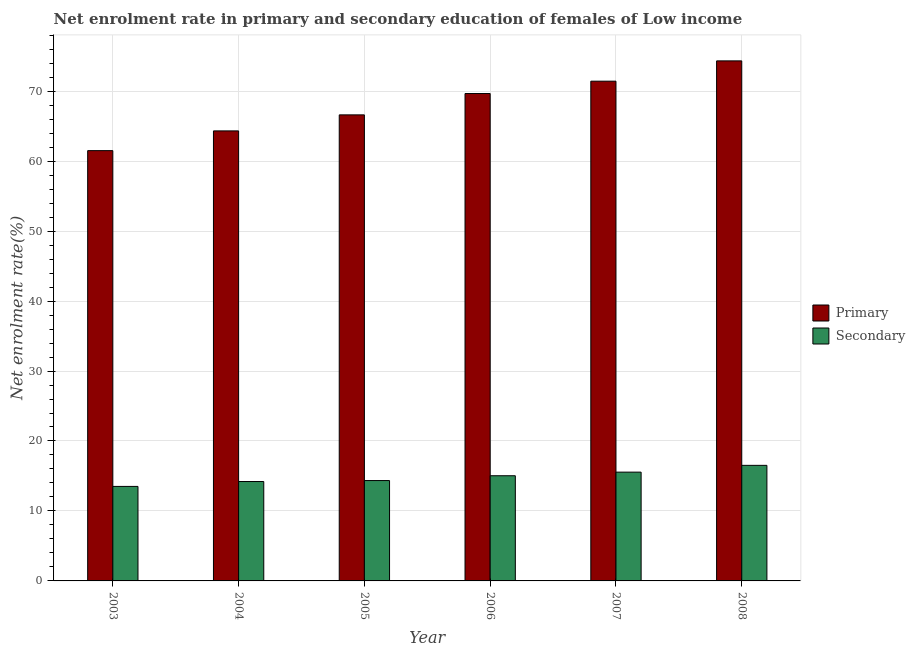How many different coloured bars are there?
Make the answer very short. 2. Are the number of bars per tick equal to the number of legend labels?
Make the answer very short. Yes. How many bars are there on the 2nd tick from the right?
Make the answer very short. 2. What is the label of the 4th group of bars from the left?
Your answer should be very brief. 2006. In how many cases, is the number of bars for a given year not equal to the number of legend labels?
Provide a short and direct response. 0. What is the enrollment rate in secondary education in 2008?
Your answer should be very brief. 16.52. Across all years, what is the maximum enrollment rate in primary education?
Keep it short and to the point. 74.33. Across all years, what is the minimum enrollment rate in primary education?
Provide a succinct answer. 61.5. In which year was the enrollment rate in primary education maximum?
Keep it short and to the point. 2008. What is the total enrollment rate in primary education in the graph?
Your answer should be compact. 407.84. What is the difference between the enrollment rate in primary education in 2006 and that in 2007?
Offer a very short reply. -1.77. What is the difference between the enrollment rate in secondary education in 2005 and the enrollment rate in primary education in 2006?
Your answer should be very brief. -0.69. What is the average enrollment rate in secondary education per year?
Ensure brevity in your answer.  14.86. What is the ratio of the enrollment rate in secondary education in 2005 to that in 2006?
Your answer should be compact. 0.95. Is the enrollment rate in secondary education in 2003 less than that in 2005?
Your response must be concise. Yes. What is the difference between the highest and the second highest enrollment rate in secondary education?
Your answer should be very brief. 0.97. What is the difference between the highest and the lowest enrollment rate in secondary education?
Your answer should be compact. 3.01. In how many years, is the enrollment rate in primary education greater than the average enrollment rate in primary education taken over all years?
Your answer should be compact. 3. What does the 1st bar from the left in 2007 represents?
Your answer should be very brief. Primary. What does the 1st bar from the right in 2005 represents?
Keep it short and to the point. Secondary. How many bars are there?
Your answer should be compact. 12. How many years are there in the graph?
Give a very brief answer. 6. What is the difference between two consecutive major ticks on the Y-axis?
Your answer should be compact. 10. Does the graph contain any zero values?
Give a very brief answer. No. Does the graph contain grids?
Your answer should be very brief. Yes. How many legend labels are there?
Your answer should be very brief. 2. How are the legend labels stacked?
Provide a succinct answer. Vertical. What is the title of the graph?
Your answer should be compact. Net enrolment rate in primary and secondary education of females of Low income. Does "Passenger Transport Items" appear as one of the legend labels in the graph?
Offer a terse response. No. What is the label or title of the X-axis?
Your answer should be very brief. Year. What is the label or title of the Y-axis?
Make the answer very short. Net enrolment rate(%). What is the Net enrolment rate(%) in Primary in 2003?
Provide a short and direct response. 61.5. What is the Net enrolment rate(%) in Secondary in 2003?
Make the answer very short. 13.51. What is the Net enrolment rate(%) in Primary in 2004?
Offer a terse response. 64.32. What is the Net enrolment rate(%) in Secondary in 2004?
Provide a succinct answer. 14.21. What is the Net enrolment rate(%) in Primary in 2005?
Provide a short and direct response. 66.61. What is the Net enrolment rate(%) of Secondary in 2005?
Your answer should be very brief. 14.35. What is the Net enrolment rate(%) of Primary in 2006?
Ensure brevity in your answer.  69.66. What is the Net enrolment rate(%) of Secondary in 2006?
Provide a succinct answer. 15.03. What is the Net enrolment rate(%) of Primary in 2007?
Keep it short and to the point. 71.43. What is the Net enrolment rate(%) in Secondary in 2007?
Provide a short and direct response. 15.55. What is the Net enrolment rate(%) of Primary in 2008?
Make the answer very short. 74.33. What is the Net enrolment rate(%) of Secondary in 2008?
Your answer should be very brief. 16.52. Across all years, what is the maximum Net enrolment rate(%) of Primary?
Make the answer very short. 74.33. Across all years, what is the maximum Net enrolment rate(%) in Secondary?
Give a very brief answer. 16.52. Across all years, what is the minimum Net enrolment rate(%) in Primary?
Make the answer very short. 61.5. Across all years, what is the minimum Net enrolment rate(%) in Secondary?
Offer a terse response. 13.51. What is the total Net enrolment rate(%) of Primary in the graph?
Provide a succinct answer. 407.84. What is the total Net enrolment rate(%) of Secondary in the graph?
Provide a short and direct response. 89.16. What is the difference between the Net enrolment rate(%) in Primary in 2003 and that in 2004?
Provide a short and direct response. -2.82. What is the difference between the Net enrolment rate(%) of Secondary in 2003 and that in 2004?
Provide a short and direct response. -0.7. What is the difference between the Net enrolment rate(%) of Primary in 2003 and that in 2005?
Make the answer very short. -5.11. What is the difference between the Net enrolment rate(%) of Secondary in 2003 and that in 2005?
Make the answer very short. -0.84. What is the difference between the Net enrolment rate(%) of Primary in 2003 and that in 2006?
Keep it short and to the point. -8.16. What is the difference between the Net enrolment rate(%) in Secondary in 2003 and that in 2006?
Give a very brief answer. -1.52. What is the difference between the Net enrolment rate(%) of Primary in 2003 and that in 2007?
Make the answer very short. -9.93. What is the difference between the Net enrolment rate(%) in Secondary in 2003 and that in 2007?
Provide a short and direct response. -2.04. What is the difference between the Net enrolment rate(%) in Primary in 2003 and that in 2008?
Your answer should be very brief. -12.83. What is the difference between the Net enrolment rate(%) in Secondary in 2003 and that in 2008?
Keep it short and to the point. -3.01. What is the difference between the Net enrolment rate(%) of Primary in 2004 and that in 2005?
Offer a terse response. -2.29. What is the difference between the Net enrolment rate(%) in Secondary in 2004 and that in 2005?
Your answer should be very brief. -0.14. What is the difference between the Net enrolment rate(%) of Primary in 2004 and that in 2006?
Offer a very short reply. -5.34. What is the difference between the Net enrolment rate(%) in Secondary in 2004 and that in 2006?
Offer a terse response. -0.83. What is the difference between the Net enrolment rate(%) in Primary in 2004 and that in 2007?
Give a very brief answer. -7.11. What is the difference between the Net enrolment rate(%) in Secondary in 2004 and that in 2007?
Ensure brevity in your answer.  -1.34. What is the difference between the Net enrolment rate(%) of Primary in 2004 and that in 2008?
Give a very brief answer. -10.01. What is the difference between the Net enrolment rate(%) of Secondary in 2004 and that in 2008?
Offer a very short reply. -2.31. What is the difference between the Net enrolment rate(%) of Primary in 2005 and that in 2006?
Your response must be concise. -3.05. What is the difference between the Net enrolment rate(%) in Secondary in 2005 and that in 2006?
Offer a terse response. -0.69. What is the difference between the Net enrolment rate(%) of Primary in 2005 and that in 2007?
Your answer should be compact. -4.82. What is the difference between the Net enrolment rate(%) in Secondary in 2005 and that in 2007?
Offer a terse response. -1.2. What is the difference between the Net enrolment rate(%) of Primary in 2005 and that in 2008?
Your response must be concise. -7.72. What is the difference between the Net enrolment rate(%) of Secondary in 2005 and that in 2008?
Give a very brief answer. -2.17. What is the difference between the Net enrolment rate(%) in Primary in 2006 and that in 2007?
Give a very brief answer. -1.77. What is the difference between the Net enrolment rate(%) of Secondary in 2006 and that in 2007?
Give a very brief answer. -0.52. What is the difference between the Net enrolment rate(%) of Primary in 2006 and that in 2008?
Make the answer very short. -4.67. What is the difference between the Net enrolment rate(%) in Secondary in 2006 and that in 2008?
Provide a short and direct response. -1.48. What is the difference between the Net enrolment rate(%) in Primary in 2007 and that in 2008?
Keep it short and to the point. -2.9. What is the difference between the Net enrolment rate(%) in Secondary in 2007 and that in 2008?
Offer a terse response. -0.97. What is the difference between the Net enrolment rate(%) of Primary in 2003 and the Net enrolment rate(%) of Secondary in 2004?
Your answer should be very brief. 47.29. What is the difference between the Net enrolment rate(%) in Primary in 2003 and the Net enrolment rate(%) in Secondary in 2005?
Provide a succinct answer. 47.15. What is the difference between the Net enrolment rate(%) in Primary in 2003 and the Net enrolment rate(%) in Secondary in 2006?
Keep it short and to the point. 46.46. What is the difference between the Net enrolment rate(%) of Primary in 2003 and the Net enrolment rate(%) of Secondary in 2007?
Offer a very short reply. 45.95. What is the difference between the Net enrolment rate(%) of Primary in 2003 and the Net enrolment rate(%) of Secondary in 2008?
Your answer should be very brief. 44.98. What is the difference between the Net enrolment rate(%) in Primary in 2004 and the Net enrolment rate(%) in Secondary in 2005?
Offer a very short reply. 49.97. What is the difference between the Net enrolment rate(%) of Primary in 2004 and the Net enrolment rate(%) of Secondary in 2006?
Your answer should be very brief. 49.29. What is the difference between the Net enrolment rate(%) in Primary in 2004 and the Net enrolment rate(%) in Secondary in 2007?
Give a very brief answer. 48.77. What is the difference between the Net enrolment rate(%) of Primary in 2004 and the Net enrolment rate(%) of Secondary in 2008?
Keep it short and to the point. 47.8. What is the difference between the Net enrolment rate(%) of Primary in 2005 and the Net enrolment rate(%) of Secondary in 2006?
Provide a short and direct response. 51.58. What is the difference between the Net enrolment rate(%) of Primary in 2005 and the Net enrolment rate(%) of Secondary in 2007?
Your answer should be very brief. 51.06. What is the difference between the Net enrolment rate(%) in Primary in 2005 and the Net enrolment rate(%) in Secondary in 2008?
Offer a terse response. 50.09. What is the difference between the Net enrolment rate(%) of Primary in 2006 and the Net enrolment rate(%) of Secondary in 2007?
Ensure brevity in your answer.  54.11. What is the difference between the Net enrolment rate(%) of Primary in 2006 and the Net enrolment rate(%) of Secondary in 2008?
Provide a succinct answer. 53.14. What is the difference between the Net enrolment rate(%) in Primary in 2007 and the Net enrolment rate(%) in Secondary in 2008?
Your response must be concise. 54.91. What is the average Net enrolment rate(%) in Primary per year?
Offer a very short reply. 67.97. What is the average Net enrolment rate(%) in Secondary per year?
Keep it short and to the point. 14.86. In the year 2003, what is the difference between the Net enrolment rate(%) of Primary and Net enrolment rate(%) of Secondary?
Offer a very short reply. 47.99. In the year 2004, what is the difference between the Net enrolment rate(%) in Primary and Net enrolment rate(%) in Secondary?
Provide a short and direct response. 50.11. In the year 2005, what is the difference between the Net enrolment rate(%) of Primary and Net enrolment rate(%) of Secondary?
Your answer should be compact. 52.27. In the year 2006, what is the difference between the Net enrolment rate(%) of Primary and Net enrolment rate(%) of Secondary?
Offer a terse response. 54.63. In the year 2007, what is the difference between the Net enrolment rate(%) in Primary and Net enrolment rate(%) in Secondary?
Your answer should be very brief. 55.88. In the year 2008, what is the difference between the Net enrolment rate(%) of Primary and Net enrolment rate(%) of Secondary?
Make the answer very short. 57.81. What is the ratio of the Net enrolment rate(%) in Primary in 2003 to that in 2004?
Give a very brief answer. 0.96. What is the ratio of the Net enrolment rate(%) in Secondary in 2003 to that in 2004?
Make the answer very short. 0.95. What is the ratio of the Net enrolment rate(%) in Primary in 2003 to that in 2005?
Give a very brief answer. 0.92. What is the ratio of the Net enrolment rate(%) in Secondary in 2003 to that in 2005?
Your response must be concise. 0.94. What is the ratio of the Net enrolment rate(%) in Primary in 2003 to that in 2006?
Make the answer very short. 0.88. What is the ratio of the Net enrolment rate(%) of Secondary in 2003 to that in 2006?
Provide a succinct answer. 0.9. What is the ratio of the Net enrolment rate(%) in Primary in 2003 to that in 2007?
Ensure brevity in your answer.  0.86. What is the ratio of the Net enrolment rate(%) of Secondary in 2003 to that in 2007?
Your response must be concise. 0.87. What is the ratio of the Net enrolment rate(%) in Primary in 2003 to that in 2008?
Make the answer very short. 0.83. What is the ratio of the Net enrolment rate(%) of Secondary in 2003 to that in 2008?
Provide a succinct answer. 0.82. What is the ratio of the Net enrolment rate(%) in Primary in 2004 to that in 2005?
Keep it short and to the point. 0.97. What is the ratio of the Net enrolment rate(%) in Secondary in 2004 to that in 2005?
Give a very brief answer. 0.99. What is the ratio of the Net enrolment rate(%) in Primary in 2004 to that in 2006?
Your answer should be very brief. 0.92. What is the ratio of the Net enrolment rate(%) in Secondary in 2004 to that in 2006?
Keep it short and to the point. 0.94. What is the ratio of the Net enrolment rate(%) in Primary in 2004 to that in 2007?
Your answer should be very brief. 0.9. What is the ratio of the Net enrolment rate(%) in Secondary in 2004 to that in 2007?
Offer a terse response. 0.91. What is the ratio of the Net enrolment rate(%) of Primary in 2004 to that in 2008?
Make the answer very short. 0.87. What is the ratio of the Net enrolment rate(%) in Secondary in 2004 to that in 2008?
Your answer should be compact. 0.86. What is the ratio of the Net enrolment rate(%) of Primary in 2005 to that in 2006?
Your response must be concise. 0.96. What is the ratio of the Net enrolment rate(%) in Secondary in 2005 to that in 2006?
Your answer should be very brief. 0.95. What is the ratio of the Net enrolment rate(%) of Primary in 2005 to that in 2007?
Give a very brief answer. 0.93. What is the ratio of the Net enrolment rate(%) of Secondary in 2005 to that in 2007?
Provide a succinct answer. 0.92. What is the ratio of the Net enrolment rate(%) of Primary in 2005 to that in 2008?
Make the answer very short. 0.9. What is the ratio of the Net enrolment rate(%) of Secondary in 2005 to that in 2008?
Provide a succinct answer. 0.87. What is the ratio of the Net enrolment rate(%) in Primary in 2006 to that in 2007?
Your response must be concise. 0.98. What is the ratio of the Net enrolment rate(%) of Secondary in 2006 to that in 2007?
Ensure brevity in your answer.  0.97. What is the ratio of the Net enrolment rate(%) in Primary in 2006 to that in 2008?
Offer a terse response. 0.94. What is the ratio of the Net enrolment rate(%) in Secondary in 2006 to that in 2008?
Provide a short and direct response. 0.91. What is the ratio of the Net enrolment rate(%) in Primary in 2007 to that in 2008?
Offer a very short reply. 0.96. What is the ratio of the Net enrolment rate(%) of Secondary in 2007 to that in 2008?
Keep it short and to the point. 0.94. What is the difference between the highest and the second highest Net enrolment rate(%) in Primary?
Your answer should be compact. 2.9. What is the difference between the highest and the second highest Net enrolment rate(%) of Secondary?
Keep it short and to the point. 0.97. What is the difference between the highest and the lowest Net enrolment rate(%) in Primary?
Your answer should be compact. 12.83. What is the difference between the highest and the lowest Net enrolment rate(%) of Secondary?
Make the answer very short. 3.01. 